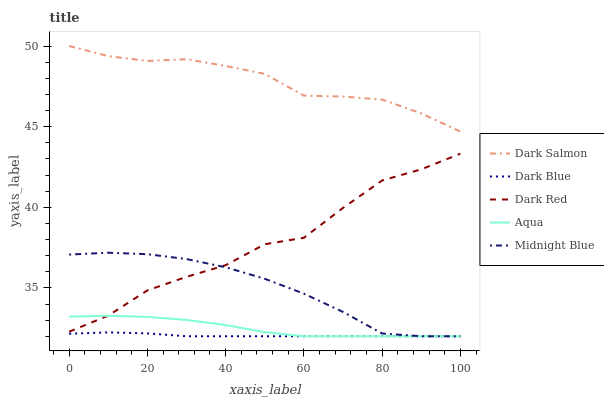Does Dark Blue have the minimum area under the curve?
Answer yes or no. Yes. Does Dark Salmon have the maximum area under the curve?
Answer yes or no. Yes. Does Midnight Blue have the minimum area under the curve?
Answer yes or no. No. Does Midnight Blue have the maximum area under the curve?
Answer yes or no. No. Is Dark Blue the smoothest?
Answer yes or no. Yes. Is Dark Red the roughest?
Answer yes or no. Yes. Is Midnight Blue the smoothest?
Answer yes or no. No. Is Midnight Blue the roughest?
Answer yes or no. No. Does Dark Blue have the lowest value?
Answer yes or no. Yes. Does Dark Salmon have the lowest value?
Answer yes or no. No. Does Dark Salmon have the highest value?
Answer yes or no. Yes. Does Midnight Blue have the highest value?
Answer yes or no. No. Is Midnight Blue less than Dark Salmon?
Answer yes or no. Yes. Is Dark Salmon greater than Midnight Blue?
Answer yes or no. Yes. Does Midnight Blue intersect Aqua?
Answer yes or no. Yes. Is Midnight Blue less than Aqua?
Answer yes or no. No. Is Midnight Blue greater than Aqua?
Answer yes or no. No. Does Midnight Blue intersect Dark Salmon?
Answer yes or no. No. 